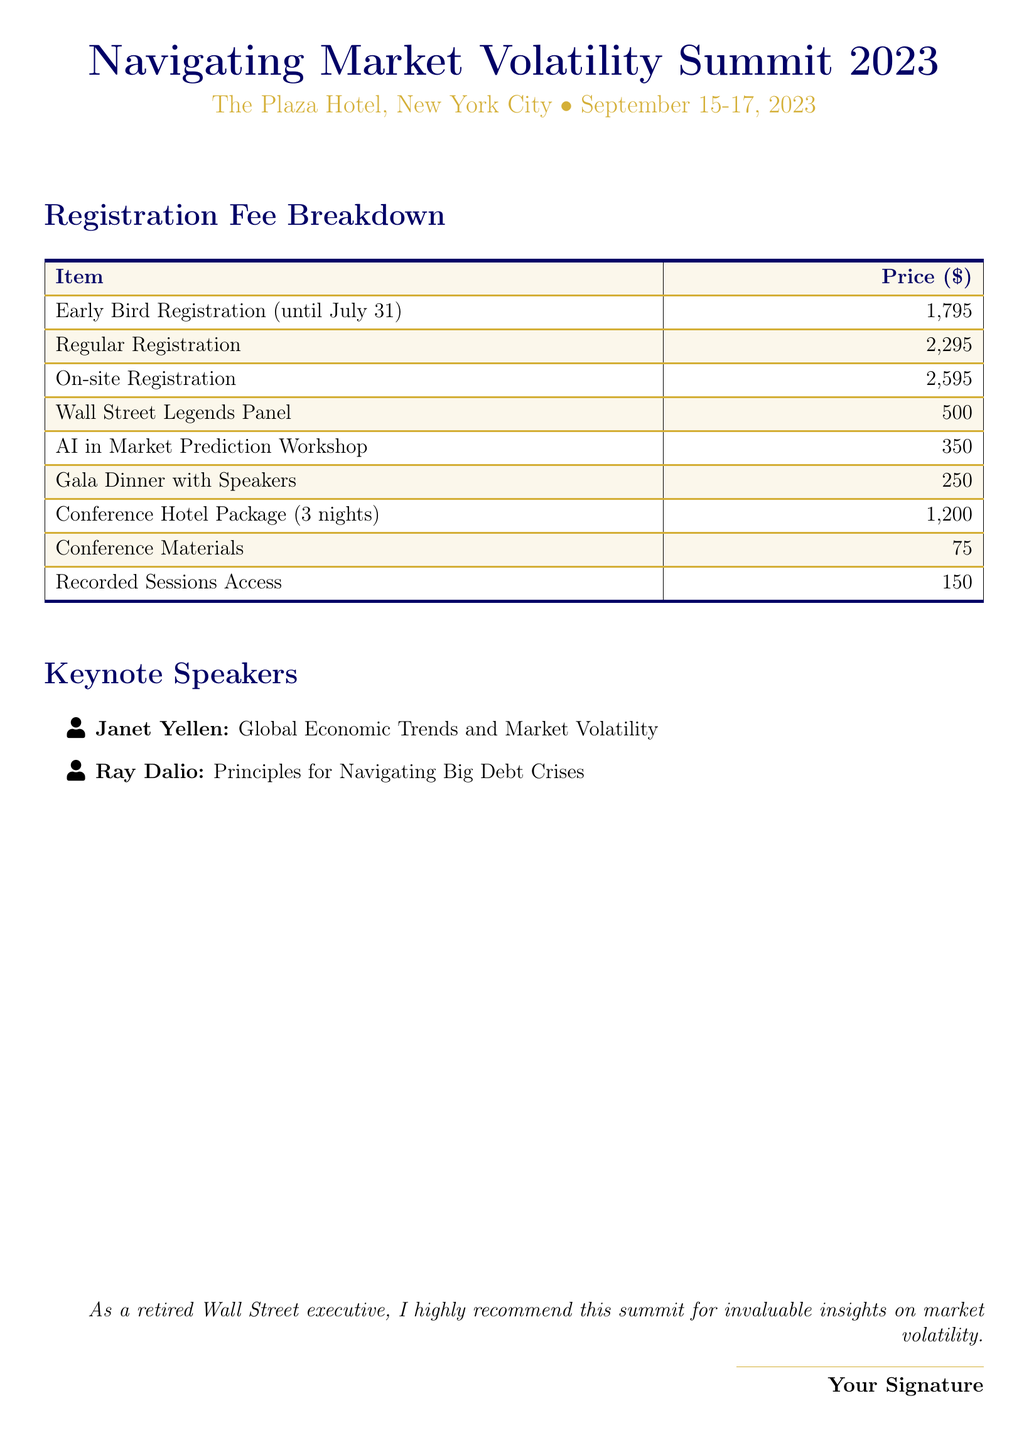What is the location of the summit? The document states that the summit will be held at The Plaza Hotel, New York City.
Answer: The Plaza Hotel, New York City What is the date range of the summit? The summit takes place from September 15 to September 17, 2023.
Answer: September 15-17, 2023 What is the price for Early Bird Registration? The Early Bird Registration fee is listed as 1,795 dollars.
Answer: 1,795 Who is one of the keynote speakers? The document mentions Janet Yellen as a keynote speaker.
Answer: Janet Yellen How much does the Gala Dinner with Speakers cost? The fee for the Gala Dinner with Speakers is 250 dollars.
Answer: 250 What is the total cost of Regular Registration and On-site Registration? To find the total, add Regular Registration (2,295) and On-site Registration (2,595) together.
Answer: 4,890 What type of talk does Ray Dalio give? Ray Dalio's talk is titled "Principles for Navigating Big Debt Crises."
Answer: Principles for Navigating Big Debt Crises What is included in the Conference Hotel Package? The Conference Hotel Package includes accommodation for 3 nights.
Answer: 3 nights What is the cost of the AI in Market Prediction Workshop? The price for the AI in Market Prediction Workshop is 350 dollars.
Answer: 350 